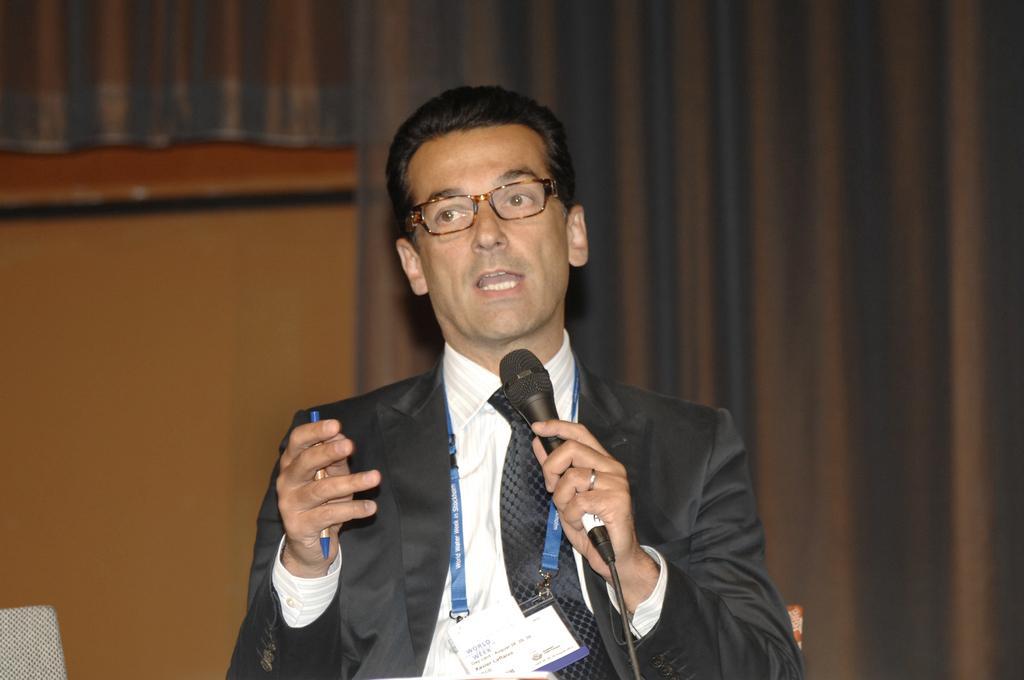How would you summarize this image in a sentence or two? In the center of the image we can see a man standing and holding a pen and in his hands. In the background there is a curtain and a wall. 